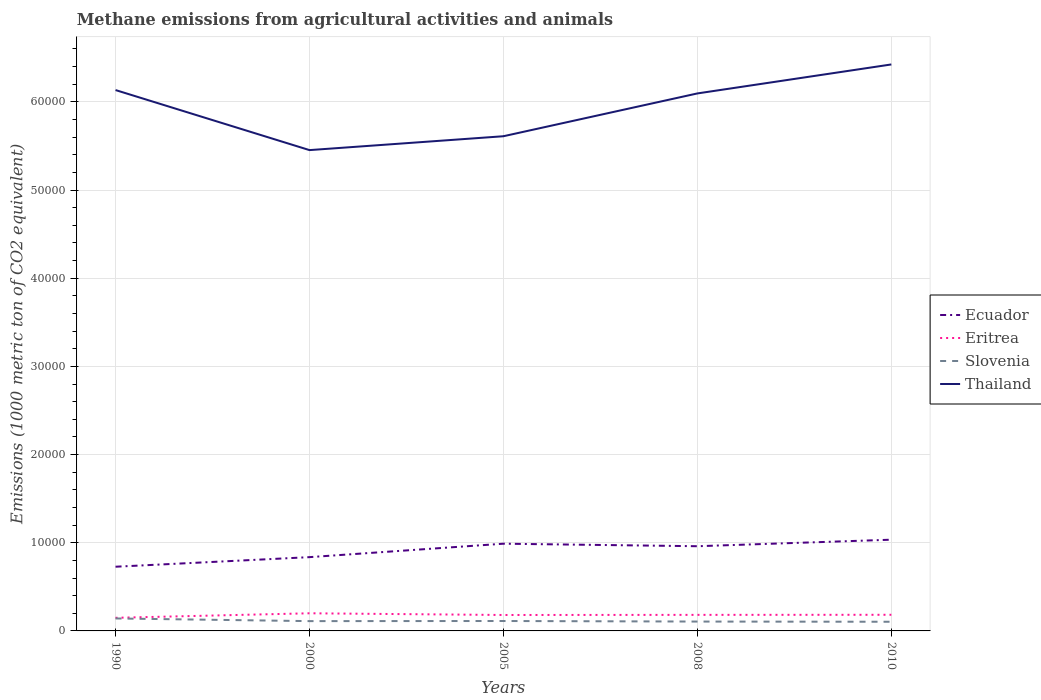How many different coloured lines are there?
Your response must be concise. 4. Does the line corresponding to Slovenia intersect with the line corresponding to Eritrea?
Your answer should be compact. No. Is the number of lines equal to the number of legend labels?
Provide a succinct answer. Yes. Across all years, what is the maximum amount of methane emitted in Thailand?
Provide a short and direct response. 5.45e+04. In which year was the amount of methane emitted in Slovenia maximum?
Make the answer very short. 2010. What is the total amount of methane emitted in Slovenia in the graph?
Your answer should be very brief. 62.8. What is the difference between the highest and the second highest amount of methane emitted in Ecuador?
Your answer should be compact. 3065.8. What is the difference between the highest and the lowest amount of methane emitted in Thailand?
Make the answer very short. 3. Is the amount of methane emitted in Slovenia strictly greater than the amount of methane emitted in Eritrea over the years?
Offer a terse response. Yes. How many years are there in the graph?
Offer a very short reply. 5. What is the difference between two consecutive major ticks on the Y-axis?
Your response must be concise. 10000. Does the graph contain any zero values?
Offer a terse response. No. Does the graph contain grids?
Provide a short and direct response. Yes. Where does the legend appear in the graph?
Offer a very short reply. Center right. How many legend labels are there?
Give a very brief answer. 4. How are the legend labels stacked?
Keep it short and to the point. Vertical. What is the title of the graph?
Your answer should be very brief. Methane emissions from agricultural activities and animals. Does "Maldives" appear as one of the legend labels in the graph?
Your answer should be compact. No. What is the label or title of the Y-axis?
Your response must be concise. Emissions (1000 metric ton of CO2 equivalent). What is the Emissions (1000 metric ton of CO2 equivalent) of Ecuador in 1990?
Make the answer very short. 7280. What is the Emissions (1000 metric ton of CO2 equivalent) in Eritrea in 1990?
Keep it short and to the point. 1488.1. What is the Emissions (1000 metric ton of CO2 equivalent) in Slovenia in 1990?
Offer a terse response. 1413.5. What is the Emissions (1000 metric ton of CO2 equivalent) in Thailand in 1990?
Offer a very short reply. 6.13e+04. What is the Emissions (1000 metric ton of CO2 equivalent) in Ecuador in 2000?
Make the answer very short. 8366.7. What is the Emissions (1000 metric ton of CO2 equivalent) of Eritrea in 2000?
Offer a very short reply. 2000.3. What is the Emissions (1000 metric ton of CO2 equivalent) in Slovenia in 2000?
Keep it short and to the point. 1111. What is the Emissions (1000 metric ton of CO2 equivalent) in Thailand in 2000?
Offer a terse response. 5.45e+04. What is the Emissions (1000 metric ton of CO2 equivalent) in Ecuador in 2005?
Offer a very short reply. 9891. What is the Emissions (1000 metric ton of CO2 equivalent) of Eritrea in 2005?
Keep it short and to the point. 1806.6. What is the Emissions (1000 metric ton of CO2 equivalent) in Slovenia in 2005?
Ensure brevity in your answer.  1124.6. What is the Emissions (1000 metric ton of CO2 equivalent) of Thailand in 2005?
Give a very brief answer. 5.61e+04. What is the Emissions (1000 metric ton of CO2 equivalent) in Ecuador in 2008?
Give a very brief answer. 9604.8. What is the Emissions (1000 metric ton of CO2 equivalent) of Eritrea in 2008?
Offer a very short reply. 1820.8. What is the Emissions (1000 metric ton of CO2 equivalent) of Slovenia in 2008?
Give a very brief answer. 1061.8. What is the Emissions (1000 metric ton of CO2 equivalent) in Thailand in 2008?
Provide a succinct answer. 6.10e+04. What is the Emissions (1000 metric ton of CO2 equivalent) in Ecuador in 2010?
Your answer should be compact. 1.03e+04. What is the Emissions (1000 metric ton of CO2 equivalent) in Eritrea in 2010?
Keep it short and to the point. 1829.8. What is the Emissions (1000 metric ton of CO2 equivalent) in Slovenia in 2010?
Give a very brief answer. 1039.4. What is the Emissions (1000 metric ton of CO2 equivalent) of Thailand in 2010?
Your answer should be very brief. 6.42e+04. Across all years, what is the maximum Emissions (1000 metric ton of CO2 equivalent) in Ecuador?
Your answer should be compact. 1.03e+04. Across all years, what is the maximum Emissions (1000 metric ton of CO2 equivalent) of Eritrea?
Give a very brief answer. 2000.3. Across all years, what is the maximum Emissions (1000 metric ton of CO2 equivalent) in Slovenia?
Provide a succinct answer. 1413.5. Across all years, what is the maximum Emissions (1000 metric ton of CO2 equivalent) of Thailand?
Offer a very short reply. 6.42e+04. Across all years, what is the minimum Emissions (1000 metric ton of CO2 equivalent) in Ecuador?
Provide a short and direct response. 7280. Across all years, what is the minimum Emissions (1000 metric ton of CO2 equivalent) of Eritrea?
Keep it short and to the point. 1488.1. Across all years, what is the minimum Emissions (1000 metric ton of CO2 equivalent) in Slovenia?
Provide a succinct answer. 1039.4. Across all years, what is the minimum Emissions (1000 metric ton of CO2 equivalent) of Thailand?
Your answer should be very brief. 5.45e+04. What is the total Emissions (1000 metric ton of CO2 equivalent) of Ecuador in the graph?
Offer a very short reply. 4.55e+04. What is the total Emissions (1000 metric ton of CO2 equivalent) in Eritrea in the graph?
Offer a terse response. 8945.6. What is the total Emissions (1000 metric ton of CO2 equivalent) of Slovenia in the graph?
Offer a terse response. 5750.3. What is the total Emissions (1000 metric ton of CO2 equivalent) of Thailand in the graph?
Your answer should be compact. 2.97e+05. What is the difference between the Emissions (1000 metric ton of CO2 equivalent) in Ecuador in 1990 and that in 2000?
Keep it short and to the point. -1086.7. What is the difference between the Emissions (1000 metric ton of CO2 equivalent) of Eritrea in 1990 and that in 2000?
Provide a short and direct response. -512.2. What is the difference between the Emissions (1000 metric ton of CO2 equivalent) of Slovenia in 1990 and that in 2000?
Your answer should be compact. 302.5. What is the difference between the Emissions (1000 metric ton of CO2 equivalent) of Thailand in 1990 and that in 2000?
Provide a succinct answer. 6808.4. What is the difference between the Emissions (1000 metric ton of CO2 equivalent) of Ecuador in 1990 and that in 2005?
Offer a very short reply. -2611. What is the difference between the Emissions (1000 metric ton of CO2 equivalent) of Eritrea in 1990 and that in 2005?
Make the answer very short. -318.5. What is the difference between the Emissions (1000 metric ton of CO2 equivalent) in Slovenia in 1990 and that in 2005?
Offer a very short reply. 288.9. What is the difference between the Emissions (1000 metric ton of CO2 equivalent) of Thailand in 1990 and that in 2005?
Offer a terse response. 5235.2. What is the difference between the Emissions (1000 metric ton of CO2 equivalent) of Ecuador in 1990 and that in 2008?
Keep it short and to the point. -2324.8. What is the difference between the Emissions (1000 metric ton of CO2 equivalent) of Eritrea in 1990 and that in 2008?
Provide a short and direct response. -332.7. What is the difference between the Emissions (1000 metric ton of CO2 equivalent) of Slovenia in 1990 and that in 2008?
Offer a terse response. 351.7. What is the difference between the Emissions (1000 metric ton of CO2 equivalent) in Thailand in 1990 and that in 2008?
Your answer should be very brief. 381.9. What is the difference between the Emissions (1000 metric ton of CO2 equivalent) in Ecuador in 1990 and that in 2010?
Make the answer very short. -3065.8. What is the difference between the Emissions (1000 metric ton of CO2 equivalent) of Eritrea in 1990 and that in 2010?
Keep it short and to the point. -341.7. What is the difference between the Emissions (1000 metric ton of CO2 equivalent) in Slovenia in 1990 and that in 2010?
Make the answer very short. 374.1. What is the difference between the Emissions (1000 metric ton of CO2 equivalent) of Thailand in 1990 and that in 2010?
Make the answer very short. -2905.8. What is the difference between the Emissions (1000 metric ton of CO2 equivalent) in Ecuador in 2000 and that in 2005?
Offer a terse response. -1524.3. What is the difference between the Emissions (1000 metric ton of CO2 equivalent) of Eritrea in 2000 and that in 2005?
Ensure brevity in your answer.  193.7. What is the difference between the Emissions (1000 metric ton of CO2 equivalent) in Slovenia in 2000 and that in 2005?
Offer a terse response. -13.6. What is the difference between the Emissions (1000 metric ton of CO2 equivalent) of Thailand in 2000 and that in 2005?
Provide a short and direct response. -1573.2. What is the difference between the Emissions (1000 metric ton of CO2 equivalent) in Ecuador in 2000 and that in 2008?
Ensure brevity in your answer.  -1238.1. What is the difference between the Emissions (1000 metric ton of CO2 equivalent) in Eritrea in 2000 and that in 2008?
Give a very brief answer. 179.5. What is the difference between the Emissions (1000 metric ton of CO2 equivalent) in Slovenia in 2000 and that in 2008?
Make the answer very short. 49.2. What is the difference between the Emissions (1000 metric ton of CO2 equivalent) of Thailand in 2000 and that in 2008?
Ensure brevity in your answer.  -6426.5. What is the difference between the Emissions (1000 metric ton of CO2 equivalent) in Ecuador in 2000 and that in 2010?
Your answer should be compact. -1979.1. What is the difference between the Emissions (1000 metric ton of CO2 equivalent) in Eritrea in 2000 and that in 2010?
Make the answer very short. 170.5. What is the difference between the Emissions (1000 metric ton of CO2 equivalent) in Slovenia in 2000 and that in 2010?
Make the answer very short. 71.6. What is the difference between the Emissions (1000 metric ton of CO2 equivalent) in Thailand in 2000 and that in 2010?
Provide a short and direct response. -9714.2. What is the difference between the Emissions (1000 metric ton of CO2 equivalent) of Ecuador in 2005 and that in 2008?
Offer a very short reply. 286.2. What is the difference between the Emissions (1000 metric ton of CO2 equivalent) in Eritrea in 2005 and that in 2008?
Your answer should be very brief. -14.2. What is the difference between the Emissions (1000 metric ton of CO2 equivalent) of Slovenia in 2005 and that in 2008?
Make the answer very short. 62.8. What is the difference between the Emissions (1000 metric ton of CO2 equivalent) in Thailand in 2005 and that in 2008?
Your answer should be very brief. -4853.3. What is the difference between the Emissions (1000 metric ton of CO2 equivalent) in Ecuador in 2005 and that in 2010?
Ensure brevity in your answer.  -454.8. What is the difference between the Emissions (1000 metric ton of CO2 equivalent) in Eritrea in 2005 and that in 2010?
Your answer should be compact. -23.2. What is the difference between the Emissions (1000 metric ton of CO2 equivalent) of Slovenia in 2005 and that in 2010?
Provide a succinct answer. 85.2. What is the difference between the Emissions (1000 metric ton of CO2 equivalent) in Thailand in 2005 and that in 2010?
Provide a succinct answer. -8141. What is the difference between the Emissions (1000 metric ton of CO2 equivalent) of Ecuador in 2008 and that in 2010?
Provide a succinct answer. -741. What is the difference between the Emissions (1000 metric ton of CO2 equivalent) in Slovenia in 2008 and that in 2010?
Make the answer very short. 22.4. What is the difference between the Emissions (1000 metric ton of CO2 equivalent) in Thailand in 2008 and that in 2010?
Provide a succinct answer. -3287.7. What is the difference between the Emissions (1000 metric ton of CO2 equivalent) in Ecuador in 1990 and the Emissions (1000 metric ton of CO2 equivalent) in Eritrea in 2000?
Your answer should be compact. 5279.7. What is the difference between the Emissions (1000 metric ton of CO2 equivalent) in Ecuador in 1990 and the Emissions (1000 metric ton of CO2 equivalent) in Slovenia in 2000?
Provide a short and direct response. 6169. What is the difference between the Emissions (1000 metric ton of CO2 equivalent) of Ecuador in 1990 and the Emissions (1000 metric ton of CO2 equivalent) of Thailand in 2000?
Offer a very short reply. -4.72e+04. What is the difference between the Emissions (1000 metric ton of CO2 equivalent) of Eritrea in 1990 and the Emissions (1000 metric ton of CO2 equivalent) of Slovenia in 2000?
Your answer should be compact. 377.1. What is the difference between the Emissions (1000 metric ton of CO2 equivalent) in Eritrea in 1990 and the Emissions (1000 metric ton of CO2 equivalent) in Thailand in 2000?
Provide a succinct answer. -5.30e+04. What is the difference between the Emissions (1000 metric ton of CO2 equivalent) of Slovenia in 1990 and the Emissions (1000 metric ton of CO2 equivalent) of Thailand in 2000?
Provide a succinct answer. -5.31e+04. What is the difference between the Emissions (1000 metric ton of CO2 equivalent) of Ecuador in 1990 and the Emissions (1000 metric ton of CO2 equivalent) of Eritrea in 2005?
Your response must be concise. 5473.4. What is the difference between the Emissions (1000 metric ton of CO2 equivalent) in Ecuador in 1990 and the Emissions (1000 metric ton of CO2 equivalent) in Slovenia in 2005?
Your answer should be compact. 6155.4. What is the difference between the Emissions (1000 metric ton of CO2 equivalent) of Ecuador in 1990 and the Emissions (1000 metric ton of CO2 equivalent) of Thailand in 2005?
Keep it short and to the point. -4.88e+04. What is the difference between the Emissions (1000 metric ton of CO2 equivalent) of Eritrea in 1990 and the Emissions (1000 metric ton of CO2 equivalent) of Slovenia in 2005?
Ensure brevity in your answer.  363.5. What is the difference between the Emissions (1000 metric ton of CO2 equivalent) in Eritrea in 1990 and the Emissions (1000 metric ton of CO2 equivalent) in Thailand in 2005?
Keep it short and to the point. -5.46e+04. What is the difference between the Emissions (1000 metric ton of CO2 equivalent) in Slovenia in 1990 and the Emissions (1000 metric ton of CO2 equivalent) in Thailand in 2005?
Your answer should be very brief. -5.47e+04. What is the difference between the Emissions (1000 metric ton of CO2 equivalent) of Ecuador in 1990 and the Emissions (1000 metric ton of CO2 equivalent) of Eritrea in 2008?
Your answer should be very brief. 5459.2. What is the difference between the Emissions (1000 metric ton of CO2 equivalent) in Ecuador in 1990 and the Emissions (1000 metric ton of CO2 equivalent) in Slovenia in 2008?
Ensure brevity in your answer.  6218.2. What is the difference between the Emissions (1000 metric ton of CO2 equivalent) of Ecuador in 1990 and the Emissions (1000 metric ton of CO2 equivalent) of Thailand in 2008?
Ensure brevity in your answer.  -5.37e+04. What is the difference between the Emissions (1000 metric ton of CO2 equivalent) in Eritrea in 1990 and the Emissions (1000 metric ton of CO2 equivalent) in Slovenia in 2008?
Your answer should be compact. 426.3. What is the difference between the Emissions (1000 metric ton of CO2 equivalent) in Eritrea in 1990 and the Emissions (1000 metric ton of CO2 equivalent) in Thailand in 2008?
Give a very brief answer. -5.95e+04. What is the difference between the Emissions (1000 metric ton of CO2 equivalent) of Slovenia in 1990 and the Emissions (1000 metric ton of CO2 equivalent) of Thailand in 2008?
Your answer should be very brief. -5.95e+04. What is the difference between the Emissions (1000 metric ton of CO2 equivalent) of Ecuador in 1990 and the Emissions (1000 metric ton of CO2 equivalent) of Eritrea in 2010?
Provide a short and direct response. 5450.2. What is the difference between the Emissions (1000 metric ton of CO2 equivalent) of Ecuador in 1990 and the Emissions (1000 metric ton of CO2 equivalent) of Slovenia in 2010?
Provide a succinct answer. 6240.6. What is the difference between the Emissions (1000 metric ton of CO2 equivalent) in Ecuador in 1990 and the Emissions (1000 metric ton of CO2 equivalent) in Thailand in 2010?
Keep it short and to the point. -5.70e+04. What is the difference between the Emissions (1000 metric ton of CO2 equivalent) in Eritrea in 1990 and the Emissions (1000 metric ton of CO2 equivalent) in Slovenia in 2010?
Give a very brief answer. 448.7. What is the difference between the Emissions (1000 metric ton of CO2 equivalent) of Eritrea in 1990 and the Emissions (1000 metric ton of CO2 equivalent) of Thailand in 2010?
Ensure brevity in your answer.  -6.28e+04. What is the difference between the Emissions (1000 metric ton of CO2 equivalent) in Slovenia in 1990 and the Emissions (1000 metric ton of CO2 equivalent) in Thailand in 2010?
Your answer should be compact. -6.28e+04. What is the difference between the Emissions (1000 metric ton of CO2 equivalent) of Ecuador in 2000 and the Emissions (1000 metric ton of CO2 equivalent) of Eritrea in 2005?
Your answer should be compact. 6560.1. What is the difference between the Emissions (1000 metric ton of CO2 equivalent) of Ecuador in 2000 and the Emissions (1000 metric ton of CO2 equivalent) of Slovenia in 2005?
Provide a succinct answer. 7242.1. What is the difference between the Emissions (1000 metric ton of CO2 equivalent) of Ecuador in 2000 and the Emissions (1000 metric ton of CO2 equivalent) of Thailand in 2005?
Provide a short and direct response. -4.77e+04. What is the difference between the Emissions (1000 metric ton of CO2 equivalent) in Eritrea in 2000 and the Emissions (1000 metric ton of CO2 equivalent) in Slovenia in 2005?
Offer a very short reply. 875.7. What is the difference between the Emissions (1000 metric ton of CO2 equivalent) in Eritrea in 2000 and the Emissions (1000 metric ton of CO2 equivalent) in Thailand in 2005?
Offer a terse response. -5.41e+04. What is the difference between the Emissions (1000 metric ton of CO2 equivalent) of Slovenia in 2000 and the Emissions (1000 metric ton of CO2 equivalent) of Thailand in 2005?
Ensure brevity in your answer.  -5.50e+04. What is the difference between the Emissions (1000 metric ton of CO2 equivalent) in Ecuador in 2000 and the Emissions (1000 metric ton of CO2 equivalent) in Eritrea in 2008?
Give a very brief answer. 6545.9. What is the difference between the Emissions (1000 metric ton of CO2 equivalent) in Ecuador in 2000 and the Emissions (1000 metric ton of CO2 equivalent) in Slovenia in 2008?
Provide a short and direct response. 7304.9. What is the difference between the Emissions (1000 metric ton of CO2 equivalent) of Ecuador in 2000 and the Emissions (1000 metric ton of CO2 equivalent) of Thailand in 2008?
Offer a terse response. -5.26e+04. What is the difference between the Emissions (1000 metric ton of CO2 equivalent) of Eritrea in 2000 and the Emissions (1000 metric ton of CO2 equivalent) of Slovenia in 2008?
Your answer should be compact. 938.5. What is the difference between the Emissions (1000 metric ton of CO2 equivalent) of Eritrea in 2000 and the Emissions (1000 metric ton of CO2 equivalent) of Thailand in 2008?
Make the answer very short. -5.90e+04. What is the difference between the Emissions (1000 metric ton of CO2 equivalent) in Slovenia in 2000 and the Emissions (1000 metric ton of CO2 equivalent) in Thailand in 2008?
Offer a terse response. -5.98e+04. What is the difference between the Emissions (1000 metric ton of CO2 equivalent) in Ecuador in 2000 and the Emissions (1000 metric ton of CO2 equivalent) in Eritrea in 2010?
Your response must be concise. 6536.9. What is the difference between the Emissions (1000 metric ton of CO2 equivalent) of Ecuador in 2000 and the Emissions (1000 metric ton of CO2 equivalent) of Slovenia in 2010?
Provide a succinct answer. 7327.3. What is the difference between the Emissions (1000 metric ton of CO2 equivalent) in Ecuador in 2000 and the Emissions (1000 metric ton of CO2 equivalent) in Thailand in 2010?
Your response must be concise. -5.59e+04. What is the difference between the Emissions (1000 metric ton of CO2 equivalent) in Eritrea in 2000 and the Emissions (1000 metric ton of CO2 equivalent) in Slovenia in 2010?
Your answer should be compact. 960.9. What is the difference between the Emissions (1000 metric ton of CO2 equivalent) of Eritrea in 2000 and the Emissions (1000 metric ton of CO2 equivalent) of Thailand in 2010?
Your answer should be very brief. -6.22e+04. What is the difference between the Emissions (1000 metric ton of CO2 equivalent) of Slovenia in 2000 and the Emissions (1000 metric ton of CO2 equivalent) of Thailand in 2010?
Provide a succinct answer. -6.31e+04. What is the difference between the Emissions (1000 metric ton of CO2 equivalent) in Ecuador in 2005 and the Emissions (1000 metric ton of CO2 equivalent) in Eritrea in 2008?
Your response must be concise. 8070.2. What is the difference between the Emissions (1000 metric ton of CO2 equivalent) in Ecuador in 2005 and the Emissions (1000 metric ton of CO2 equivalent) in Slovenia in 2008?
Make the answer very short. 8829.2. What is the difference between the Emissions (1000 metric ton of CO2 equivalent) in Ecuador in 2005 and the Emissions (1000 metric ton of CO2 equivalent) in Thailand in 2008?
Your answer should be very brief. -5.11e+04. What is the difference between the Emissions (1000 metric ton of CO2 equivalent) of Eritrea in 2005 and the Emissions (1000 metric ton of CO2 equivalent) of Slovenia in 2008?
Ensure brevity in your answer.  744.8. What is the difference between the Emissions (1000 metric ton of CO2 equivalent) of Eritrea in 2005 and the Emissions (1000 metric ton of CO2 equivalent) of Thailand in 2008?
Offer a terse response. -5.91e+04. What is the difference between the Emissions (1000 metric ton of CO2 equivalent) of Slovenia in 2005 and the Emissions (1000 metric ton of CO2 equivalent) of Thailand in 2008?
Provide a short and direct response. -5.98e+04. What is the difference between the Emissions (1000 metric ton of CO2 equivalent) in Ecuador in 2005 and the Emissions (1000 metric ton of CO2 equivalent) in Eritrea in 2010?
Provide a succinct answer. 8061.2. What is the difference between the Emissions (1000 metric ton of CO2 equivalent) in Ecuador in 2005 and the Emissions (1000 metric ton of CO2 equivalent) in Slovenia in 2010?
Offer a terse response. 8851.6. What is the difference between the Emissions (1000 metric ton of CO2 equivalent) in Ecuador in 2005 and the Emissions (1000 metric ton of CO2 equivalent) in Thailand in 2010?
Offer a terse response. -5.43e+04. What is the difference between the Emissions (1000 metric ton of CO2 equivalent) of Eritrea in 2005 and the Emissions (1000 metric ton of CO2 equivalent) of Slovenia in 2010?
Give a very brief answer. 767.2. What is the difference between the Emissions (1000 metric ton of CO2 equivalent) in Eritrea in 2005 and the Emissions (1000 metric ton of CO2 equivalent) in Thailand in 2010?
Provide a succinct answer. -6.24e+04. What is the difference between the Emissions (1000 metric ton of CO2 equivalent) in Slovenia in 2005 and the Emissions (1000 metric ton of CO2 equivalent) in Thailand in 2010?
Offer a very short reply. -6.31e+04. What is the difference between the Emissions (1000 metric ton of CO2 equivalent) of Ecuador in 2008 and the Emissions (1000 metric ton of CO2 equivalent) of Eritrea in 2010?
Your answer should be very brief. 7775. What is the difference between the Emissions (1000 metric ton of CO2 equivalent) of Ecuador in 2008 and the Emissions (1000 metric ton of CO2 equivalent) of Slovenia in 2010?
Ensure brevity in your answer.  8565.4. What is the difference between the Emissions (1000 metric ton of CO2 equivalent) in Ecuador in 2008 and the Emissions (1000 metric ton of CO2 equivalent) in Thailand in 2010?
Your answer should be compact. -5.46e+04. What is the difference between the Emissions (1000 metric ton of CO2 equivalent) in Eritrea in 2008 and the Emissions (1000 metric ton of CO2 equivalent) in Slovenia in 2010?
Your answer should be compact. 781.4. What is the difference between the Emissions (1000 metric ton of CO2 equivalent) in Eritrea in 2008 and the Emissions (1000 metric ton of CO2 equivalent) in Thailand in 2010?
Your response must be concise. -6.24e+04. What is the difference between the Emissions (1000 metric ton of CO2 equivalent) in Slovenia in 2008 and the Emissions (1000 metric ton of CO2 equivalent) in Thailand in 2010?
Offer a very short reply. -6.32e+04. What is the average Emissions (1000 metric ton of CO2 equivalent) of Ecuador per year?
Offer a very short reply. 9097.66. What is the average Emissions (1000 metric ton of CO2 equivalent) in Eritrea per year?
Offer a terse response. 1789.12. What is the average Emissions (1000 metric ton of CO2 equivalent) in Slovenia per year?
Your answer should be compact. 1150.06. What is the average Emissions (1000 metric ton of CO2 equivalent) in Thailand per year?
Offer a terse response. 5.94e+04. In the year 1990, what is the difference between the Emissions (1000 metric ton of CO2 equivalent) of Ecuador and Emissions (1000 metric ton of CO2 equivalent) of Eritrea?
Keep it short and to the point. 5791.9. In the year 1990, what is the difference between the Emissions (1000 metric ton of CO2 equivalent) in Ecuador and Emissions (1000 metric ton of CO2 equivalent) in Slovenia?
Provide a short and direct response. 5866.5. In the year 1990, what is the difference between the Emissions (1000 metric ton of CO2 equivalent) of Ecuador and Emissions (1000 metric ton of CO2 equivalent) of Thailand?
Keep it short and to the point. -5.41e+04. In the year 1990, what is the difference between the Emissions (1000 metric ton of CO2 equivalent) in Eritrea and Emissions (1000 metric ton of CO2 equivalent) in Slovenia?
Give a very brief answer. 74.6. In the year 1990, what is the difference between the Emissions (1000 metric ton of CO2 equivalent) in Eritrea and Emissions (1000 metric ton of CO2 equivalent) in Thailand?
Provide a short and direct response. -5.98e+04. In the year 1990, what is the difference between the Emissions (1000 metric ton of CO2 equivalent) of Slovenia and Emissions (1000 metric ton of CO2 equivalent) of Thailand?
Keep it short and to the point. -5.99e+04. In the year 2000, what is the difference between the Emissions (1000 metric ton of CO2 equivalent) in Ecuador and Emissions (1000 metric ton of CO2 equivalent) in Eritrea?
Make the answer very short. 6366.4. In the year 2000, what is the difference between the Emissions (1000 metric ton of CO2 equivalent) of Ecuador and Emissions (1000 metric ton of CO2 equivalent) of Slovenia?
Offer a very short reply. 7255.7. In the year 2000, what is the difference between the Emissions (1000 metric ton of CO2 equivalent) of Ecuador and Emissions (1000 metric ton of CO2 equivalent) of Thailand?
Ensure brevity in your answer.  -4.62e+04. In the year 2000, what is the difference between the Emissions (1000 metric ton of CO2 equivalent) of Eritrea and Emissions (1000 metric ton of CO2 equivalent) of Slovenia?
Your answer should be compact. 889.3. In the year 2000, what is the difference between the Emissions (1000 metric ton of CO2 equivalent) of Eritrea and Emissions (1000 metric ton of CO2 equivalent) of Thailand?
Give a very brief answer. -5.25e+04. In the year 2000, what is the difference between the Emissions (1000 metric ton of CO2 equivalent) of Slovenia and Emissions (1000 metric ton of CO2 equivalent) of Thailand?
Offer a very short reply. -5.34e+04. In the year 2005, what is the difference between the Emissions (1000 metric ton of CO2 equivalent) in Ecuador and Emissions (1000 metric ton of CO2 equivalent) in Eritrea?
Your response must be concise. 8084.4. In the year 2005, what is the difference between the Emissions (1000 metric ton of CO2 equivalent) in Ecuador and Emissions (1000 metric ton of CO2 equivalent) in Slovenia?
Ensure brevity in your answer.  8766.4. In the year 2005, what is the difference between the Emissions (1000 metric ton of CO2 equivalent) in Ecuador and Emissions (1000 metric ton of CO2 equivalent) in Thailand?
Provide a short and direct response. -4.62e+04. In the year 2005, what is the difference between the Emissions (1000 metric ton of CO2 equivalent) in Eritrea and Emissions (1000 metric ton of CO2 equivalent) in Slovenia?
Provide a short and direct response. 682. In the year 2005, what is the difference between the Emissions (1000 metric ton of CO2 equivalent) in Eritrea and Emissions (1000 metric ton of CO2 equivalent) in Thailand?
Your answer should be compact. -5.43e+04. In the year 2005, what is the difference between the Emissions (1000 metric ton of CO2 equivalent) of Slovenia and Emissions (1000 metric ton of CO2 equivalent) of Thailand?
Offer a very short reply. -5.50e+04. In the year 2008, what is the difference between the Emissions (1000 metric ton of CO2 equivalent) of Ecuador and Emissions (1000 metric ton of CO2 equivalent) of Eritrea?
Offer a terse response. 7784. In the year 2008, what is the difference between the Emissions (1000 metric ton of CO2 equivalent) in Ecuador and Emissions (1000 metric ton of CO2 equivalent) in Slovenia?
Keep it short and to the point. 8543. In the year 2008, what is the difference between the Emissions (1000 metric ton of CO2 equivalent) in Ecuador and Emissions (1000 metric ton of CO2 equivalent) in Thailand?
Keep it short and to the point. -5.13e+04. In the year 2008, what is the difference between the Emissions (1000 metric ton of CO2 equivalent) of Eritrea and Emissions (1000 metric ton of CO2 equivalent) of Slovenia?
Provide a short and direct response. 759. In the year 2008, what is the difference between the Emissions (1000 metric ton of CO2 equivalent) of Eritrea and Emissions (1000 metric ton of CO2 equivalent) of Thailand?
Your answer should be very brief. -5.91e+04. In the year 2008, what is the difference between the Emissions (1000 metric ton of CO2 equivalent) of Slovenia and Emissions (1000 metric ton of CO2 equivalent) of Thailand?
Your answer should be very brief. -5.99e+04. In the year 2010, what is the difference between the Emissions (1000 metric ton of CO2 equivalent) in Ecuador and Emissions (1000 metric ton of CO2 equivalent) in Eritrea?
Make the answer very short. 8516. In the year 2010, what is the difference between the Emissions (1000 metric ton of CO2 equivalent) of Ecuador and Emissions (1000 metric ton of CO2 equivalent) of Slovenia?
Your answer should be compact. 9306.4. In the year 2010, what is the difference between the Emissions (1000 metric ton of CO2 equivalent) in Ecuador and Emissions (1000 metric ton of CO2 equivalent) in Thailand?
Make the answer very short. -5.39e+04. In the year 2010, what is the difference between the Emissions (1000 metric ton of CO2 equivalent) of Eritrea and Emissions (1000 metric ton of CO2 equivalent) of Slovenia?
Give a very brief answer. 790.4. In the year 2010, what is the difference between the Emissions (1000 metric ton of CO2 equivalent) of Eritrea and Emissions (1000 metric ton of CO2 equivalent) of Thailand?
Give a very brief answer. -6.24e+04. In the year 2010, what is the difference between the Emissions (1000 metric ton of CO2 equivalent) in Slovenia and Emissions (1000 metric ton of CO2 equivalent) in Thailand?
Offer a terse response. -6.32e+04. What is the ratio of the Emissions (1000 metric ton of CO2 equivalent) of Ecuador in 1990 to that in 2000?
Give a very brief answer. 0.87. What is the ratio of the Emissions (1000 metric ton of CO2 equivalent) in Eritrea in 1990 to that in 2000?
Keep it short and to the point. 0.74. What is the ratio of the Emissions (1000 metric ton of CO2 equivalent) in Slovenia in 1990 to that in 2000?
Ensure brevity in your answer.  1.27. What is the ratio of the Emissions (1000 metric ton of CO2 equivalent) in Thailand in 1990 to that in 2000?
Keep it short and to the point. 1.12. What is the ratio of the Emissions (1000 metric ton of CO2 equivalent) in Ecuador in 1990 to that in 2005?
Offer a terse response. 0.74. What is the ratio of the Emissions (1000 metric ton of CO2 equivalent) in Eritrea in 1990 to that in 2005?
Provide a succinct answer. 0.82. What is the ratio of the Emissions (1000 metric ton of CO2 equivalent) of Slovenia in 1990 to that in 2005?
Offer a very short reply. 1.26. What is the ratio of the Emissions (1000 metric ton of CO2 equivalent) in Thailand in 1990 to that in 2005?
Offer a terse response. 1.09. What is the ratio of the Emissions (1000 metric ton of CO2 equivalent) of Ecuador in 1990 to that in 2008?
Offer a very short reply. 0.76. What is the ratio of the Emissions (1000 metric ton of CO2 equivalent) in Eritrea in 1990 to that in 2008?
Offer a terse response. 0.82. What is the ratio of the Emissions (1000 metric ton of CO2 equivalent) of Slovenia in 1990 to that in 2008?
Your answer should be compact. 1.33. What is the ratio of the Emissions (1000 metric ton of CO2 equivalent) of Thailand in 1990 to that in 2008?
Offer a very short reply. 1.01. What is the ratio of the Emissions (1000 metric ton of CO2 equivalent) in Ecuador in 1990 to that in 2010?
Ensure brevity in your answer.  0.7. What is the ratio of the Emissions (1000 metric ton of CO2 equivalent) in Eritrea in 1990 to that in 2010?
Provide a short and direct response. 0.81. What is the ratio of the Emissions (1000 metric ton of CO2 equivalent) of Slovenia in 1990 to that in 2010?
Make the answer very short. 1.36. What is the ratio of the Emissions (1000 metric ton of CO2 equivalent) in Thailand in 1990 to that in 2010?
Provide a succinct answer. 0.95. What is the ratio of the Emissions (1000 metric ton of CO2 equivalent) in Ecuador in 2000 to that in 2005?
Your answer should be compact. 0.85. What is the ratio of the Emissions (1000 metric ton of CO2 equivalent) in Eritrea in 2000 to that in 2005?
Your answer should be very brief. 1.11. What is the ratio of the Emissions (1000 metric ton of CO2 equivalent) of Slovenia in 2000 to that in 2005?
Offer a very short reply. 0.99. What is the ratio of the Emissions (1000 metric ton of CO2 equivalent) of Ecuador in 2000 to that in 2008?
Keep it short and to the point. 0.87. What is the ratio of the Emissions (1000 metric ton of CO2 equivalent) of Eritrea in 2000 to that in 2008?
Keep it short and to the point. 1.1. What is the ratio of the Emissions (1000 metric ton of CO2 equivalent) in Slovenia in 2000 to that in 2008?
Keep it short and to the point. 1.05. What is the ratio of the Emissions (1000 metric ton of CO2 equivalent) of Thailand in 2000 to that in 2008?
Your answer should be compact. 0.89. What is the ratio of the Emissions (1000 metric ton of CO2 equivalent) of Ecuador in 2000 to that in 2010?
Your answer should be compact. 0.81. What is the ratio of the Emissions (1000 metric ton of CO2 equivalent) in Eritrea in 2000 to that in 2010?
Provide a succinct answer. 1.09. What is the ratio of the Emissions (1000 metric ton of CO2 equivalent) of Slovenia in 2000 to that in 2010?
Keep it short and to the point. 1.07. What is the ratio of the Emissions (1000 metric ton of CO2 equivalent) of Thailand in 2000 to that in 2010?
Offer a very short reply. 0.85. What is the ratio of the Emissions (1000 metric ton of CO2 equivalent) of Ecuador in 2005 to that in 2008?
Your response must be concise. 1.03. What is the ratio of the Emissions (1000 metric ton of CO2 equivalent) in Eritrea in 2005 to that in 2008?
Offer a terse response. 0.99. What is the ratio of the Emissions (1000 metric ton of CO2 equivalent) in Slovenia in 2005 to that in 2008?
Offer a very short reply. 1.06. What is the ratio of the Emissions (1000 metric ton of CO2 equivalent) of Thailand in 2005 to that in 2008?
Your answer should be very brief. 0.92. What is the ratio of the Emissions (1000 metric ton of CO2 equivalent) in Ecuador in 2005 to that in 2010?
Ensure brevity in your answer.  0.96. What is the ratio of the Emissions (1000 metric ton of CO2 equivalent) of Eritrea in 2005 to that in 2010?
Make the answer very short. 0.99. What is the ratio of the Emissions (1000 metric ton of CO2 equivalent) in Slovenia in 2005 to that in 2010?
Offer a very short reply. 1.08. What is the ratio of the Emissions (1000 metric ton of CO2 equivalent) in Thailand in 2005 to that in 2010?
Provide a succinct answer. 0.87. What is the ratio of the Emissions (1000 metric ton of CO2 equivalent) of Ecuador in 2008 to that in 2010?
Keep it short and to the point. 0.93. What is the ratio of the Emissions (1000 metric ton of CO2 equivalent) in Slovenia in 2008 to that in 2010?
Offer a very short reply. 1.02. What is the ratio of the Emissions (1000 metric ton of CO2 equivalent) of Thailand in 2008 to that in 2010?
Make the answer very short. 0.95. What is the difference between the highest and the second highest Emissions (1000 metric ton of CO2 equivalent) of Ecuador?
Keep it short and to the point. 454.8. What is the difference between the highest and the second highest Emissions (1000 metric ton of CO2 equivalent) of Eritrea?
Offer a very short reply. 170.5. What is the difference between the highest and the second highest Emissions (1000 metric ton of CO2 equivalent) of Slovenia?
Offer a very short reply. 288.9. What is the difference between the highest and the second highest Emissions (1000 metric ton of CO2 equivalent) of Thailand?
Give a very brief answer. 2905.8. What is the difference between the highest and the lowest Emissions (1000 metric ton of CO2 equivalent) of Ecuador?
Your answer should be compact. 3065.8. What is the difference between the highest and the lowest Emissions (1000 metric ton of CO2 equivalent) of Eritrea?
Ensure brevity in your answer.  512.2. What is the difference between the highest and the lowest Emissions (1000 metric ton of CO2 equivalent) in Slovenia?
Offer a very short reply. 374.1. What is the difference between the highest and the lowest Emissions (1000 metric ton of CO2 equivalent) in Thailand?
Make the answer very short. 9714.2. 